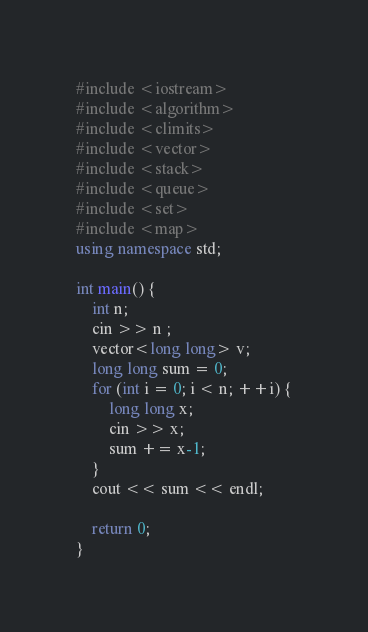Convert code to text. <code><loc_0><loc_0><loc_500><loc_500><_C++_>#include <iostream>
#include <algorithm>
#include <climits>
#include <vector>
#include <stack>
#include <queue>
#include <set>
#include <map>
using namespace std;

int main() {
    int n;
    cin >> n ;
    vector<long long> v;
    long long sum = 0;
    for (int i = 0; i < n; ++i) {
        long long x;
        cin >> x;
        sum += x-1;
    }
    cout << sum << endl;

    return 0;
}
</code> 